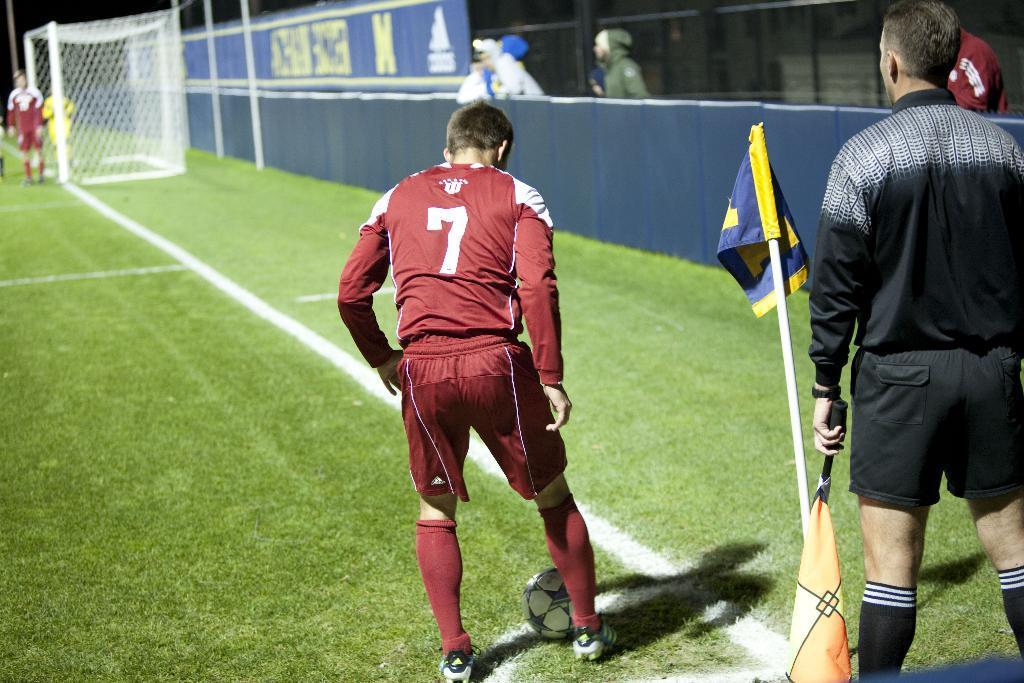In one or two sentences, can you explain what this image depicts? These persons are standing. We can see new,grass,flag with stand. This person holding flag. This is ball. 